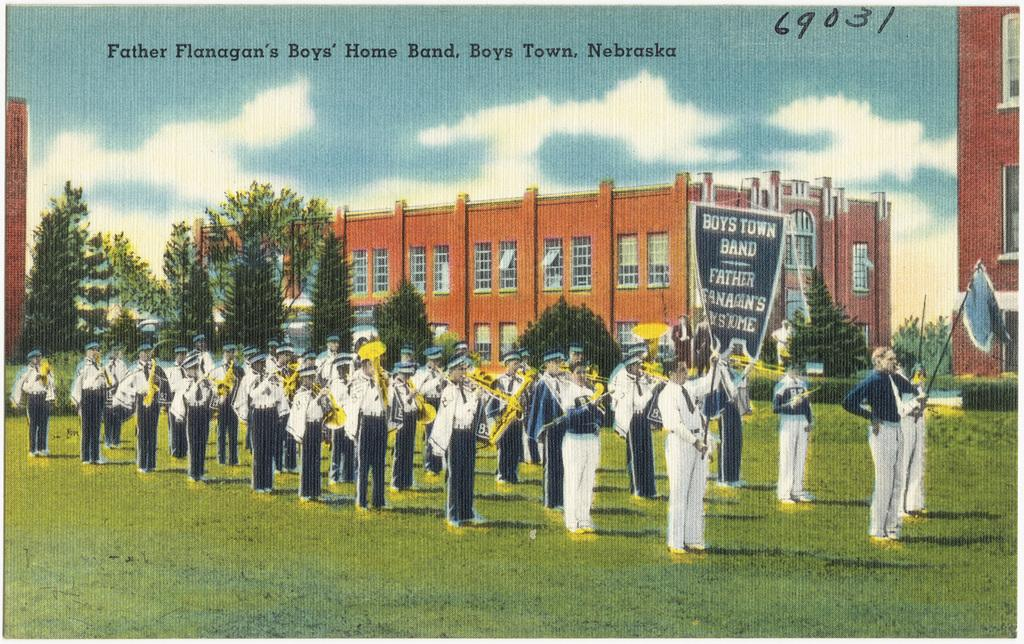<image>
Relay a brief, clear account of the picture shown. A group of band members march outside for Boys Town Band. 